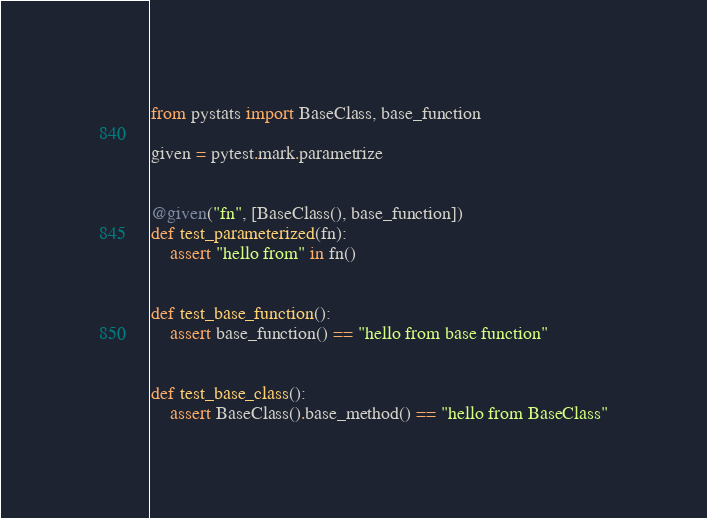<code> <loc_0><loc_0><loc_500><loc_500><_Python_>from pystats import BaseClass, base_function

given = pytest.mark.parametrize


@given("fn", [BaseClass(), base_function])
def test_parameterized(fn):
    assert "hello from" in fn()


def test_base_function():
    assert base_function() == "hello from base function"


def test_base_class():
    assert BaseClass().base_method() == "hello from BaseClass"
</code> 